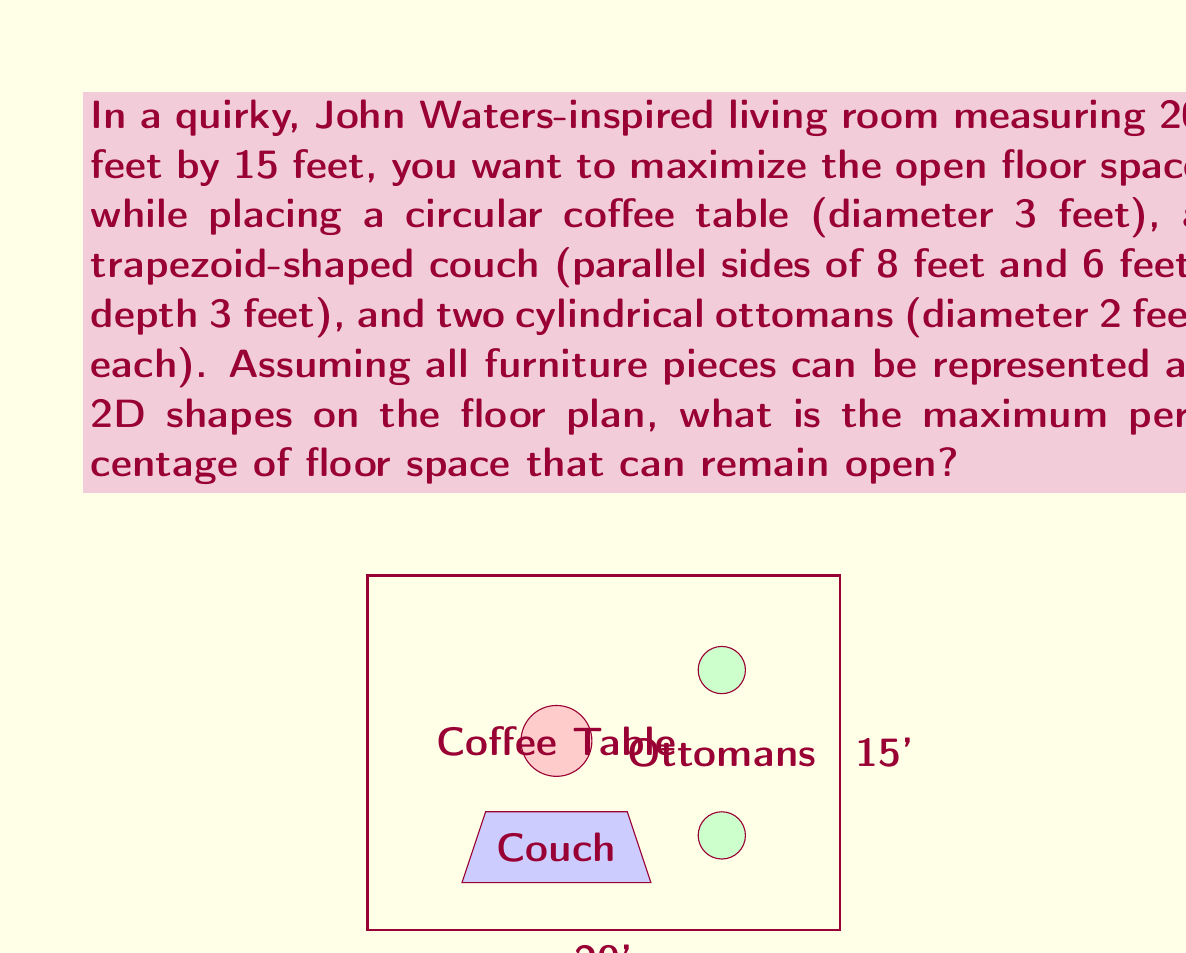Can you answer this question? To solve this problem, we need to:
1. Calculate the total floor area
2. Calculate the area occupied by each furniture piece
3. Sum up the total furniture area
4. Calculate the remaining open floor space

Step 1: Total floor area
$$ A_{total} = 20 \text{ ft} \times 15 \text{ ft} = 300 \text{ ft}^2 $$

Step 2: Area of each furniture piece
a) Circular coffee table:
$$ A_{table} = \pi r^2 = \pi (1.5 \text{ ft})^2 = 7.0686 \text{ ft}^2 $$

b) Trapezoid-shaped couch:
$$ A_{couch} = \frac{1}{2}(8 \text{ ft} + 6 \text{ ft}) \times 3 \text{ ft} = 21 \text{ ft}^2 $$

c) Two cylindrical ottomans:
$$ A_{ottomans} = 2 \times \pi r^2 = 2 \times \pi (1 \text{ ft})^2 = 6.2832 \text{ ft}^2 $$

Step 3: Total furniture area
$$ A_{furniture} = A_{table} + A_{couch} + A_{ottomans} $$
$$ A_{furniture} = 7.0686 + 21 + 6.2832 = 34.3518 \text{ ft}^2 $$

Step 4: Remaining open floor space
$$ A_{open} = A_{total} - A_{furniture} = 300 - 34.3518 = 265.6482 \text{ ft}^2 $$

Percentage of open floor space:
$$ \text{Percentage} = \frac{A_{open}}{A_{total}} \times 100\% $$
$$ \text{Percentage} = \frac{265.6482}{300} \times 100\% = 88.5494\% $$
Answer: The maximum percentage of floor space that can remain open is approximately 88.55%. 